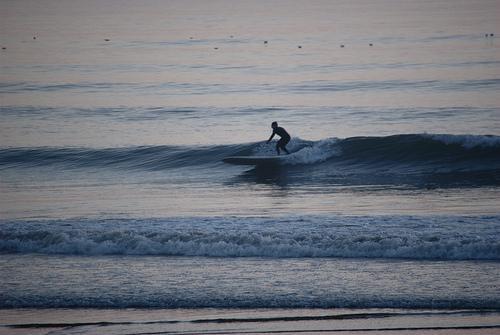How many surfers?
Give a very brief answer. 1. 